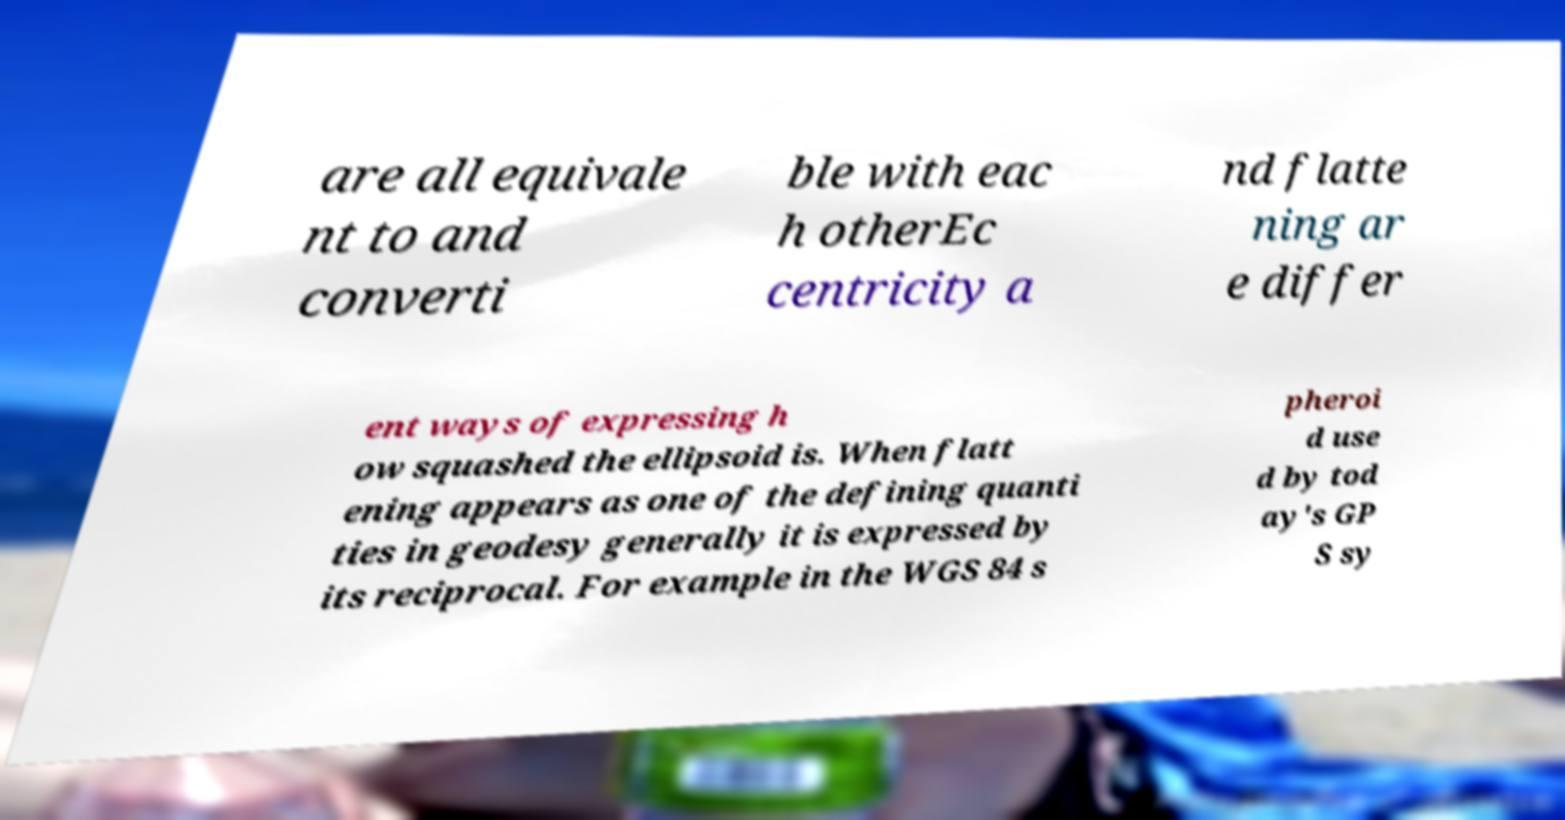Could you assist in decoding the text presented in this image and type it out clearly? are all equivale nt to and converti ble with eac h otherEc centricity a nd flatte ning ar e differ ent ways of expressing h ow squashed the ellipsoid is. When flatt ening appears as one of the defining quanti ties in geodesy generally it is expressed by its reciprocal. For example in the WGS 84 s pheroi d use d by tod ay's GP S sy 